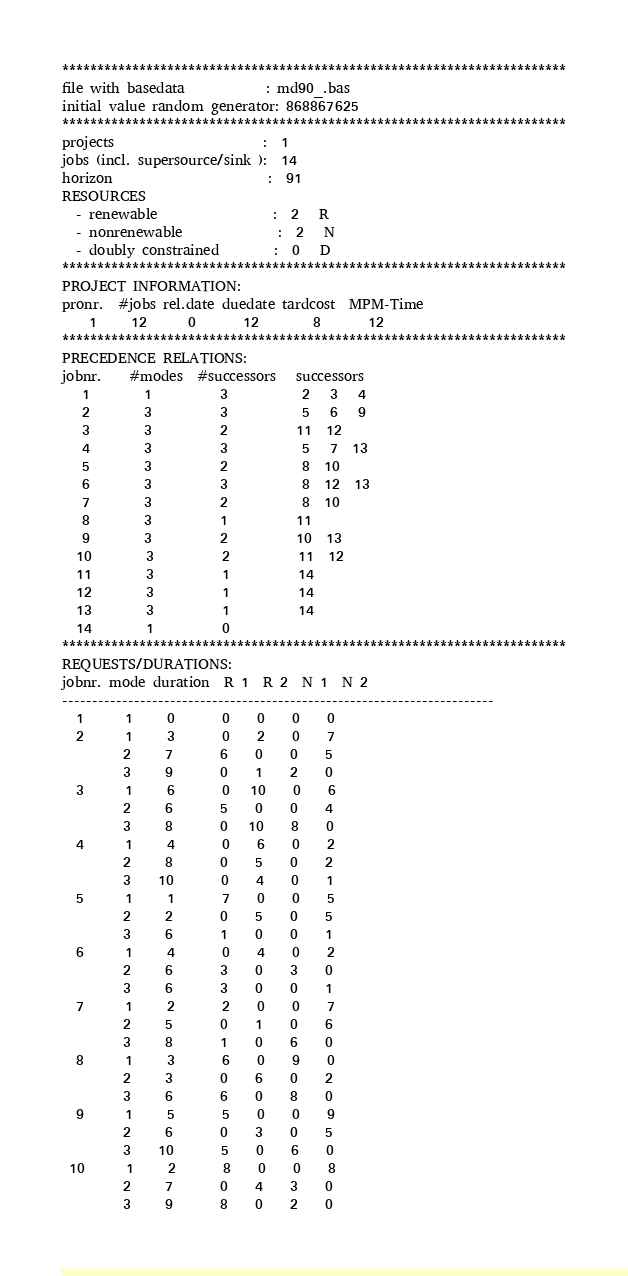Convert code to text. <code><loc_0><loc_0><loc_500><loc_500><_ObjectiveC_>************************************************************************
file with basedata            : md90_.bas
initial value random generator: 868867625
************************************************************************
projects                      :  1
jobs (incl. supersource/sink ):  14
horizon                       :  91
RESOURCES
  - renewable                 :  2   R
  - nonrenewable              :  2   N
  - doubly constrained        :  0   D
************************************************************************
PROJECT INFORMATION:
pronr.  #jobs rel.date duedate tardcost  MPM-Time
    1     12      0       12        8       12
************************************************************************
PRECEDENCE RELATIONS:
jobnr.    #modes  #successors   successors
   1        1          3           2   3   4
   2        3          3           5   6   9
   3        3          2          11  12
   4        3          3           5   7  13
   5        3          2           8  10
   6        3          3           8  12  13
   7        3          2           8  10
   8        3          1          11
   9        3          2          10  13
  10        3          2          11  12
  11        3          1          14
  12        3          1          14
  13        3          1          14
  14        1          0        
************************************************************************
REQUESTS/DURATIONS:
jobnr. mode duration  R 1  R 2  N 1  N 2
------------------------------------------------------------------------
  1      1     0       0    0    0    0
  2      1     3       0    2    0    7
         2     7       6    0    0    5
         3     9       0    1    2    0
  3      1     6       0   10    0    6
         2     6       5    0    0    4
         3     8       0   10    8    0
  4      1     4       0    6    0    2
         2     8       0    5    0    2
         3    10       0    4    0    1
  5      1     1       7    0    0    5
         2     2       0    5    0    5
         3     6       1    0    0    1
  6      1     4       0    4    0    2
         2     6       3    0    3    0
         3     6       3    0    0    1
  7      1     2       2    0    0    7
         2     5       0    1    0    6
         3     8       1    0    6    0
  8      1     3       6    0    9    0
         2     3       0    6    0    2
         3     6       6    0    8    0
  9      1     5       5    0    0    9
         2     6       0    3    0    5
         3    10       5    0    6    0
 10      1     2       8    0    0    8
         2     7       0    4    3    0
         3     9       8    0    2    0</code> 